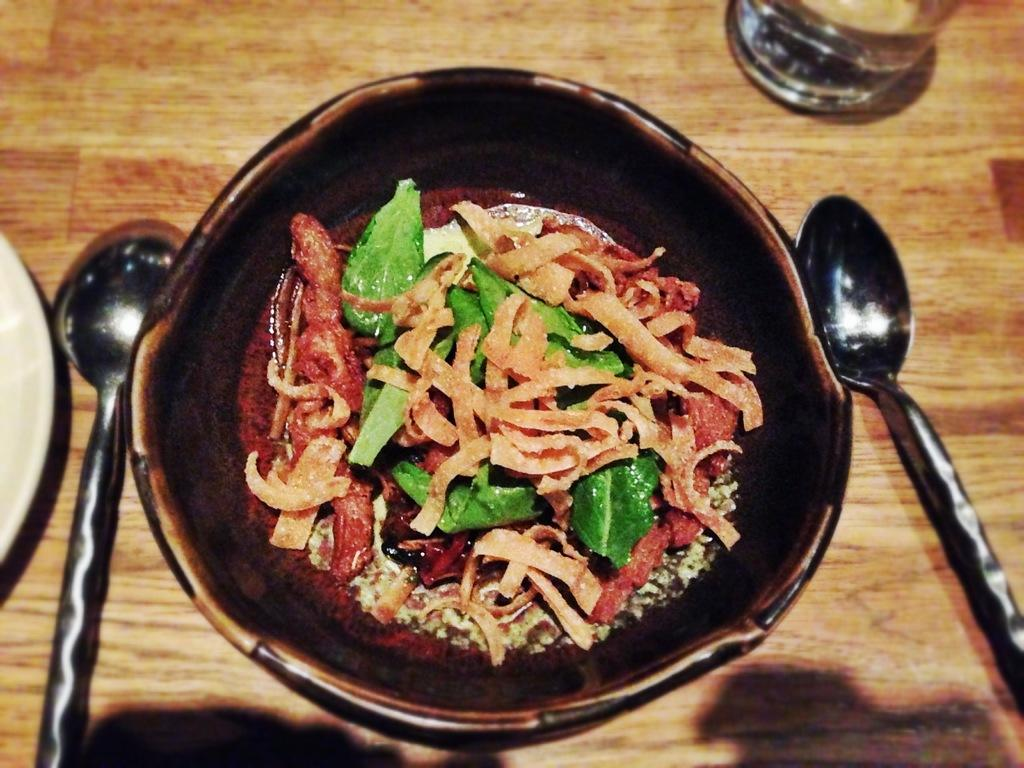What is in the bowl that is visible in the image? There is food in a bowl in the image. What is the bowl resting on in the image? The bowl is on a wooden object. What utensils are present on the wooden object? There are spoons on the wooden object. What other dish is present on the wooden object? There is a plate on the wooden object. What type of container is present on the wooden object for holding liquids? There is a glass on the wooden object. What type of plantation is visible in the image? There is no plantation present in the image; it features a bowl of food, spoons, a plate, a glass, and a wooden object. What is the relation between the food in the bowl and the kettle in the image? There is no kettle present in the image, so there is no relation between the food in the bowl and a kettle. 